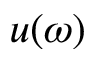Convert formula to latex. <formula><loc_0><loc_0><loc_500><loc_500>u ( \omega )</formula> 